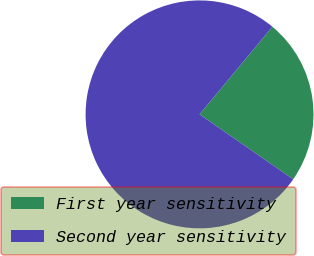Convert chart to OTSL. <chart><loc_0><loc_0><loc_500><loc_500><pie_chart><fcel>First year sensitivity<fcel>Second year sensitivity<nl><fcel>23.61%<fcel>76.39%<nl></chart> 